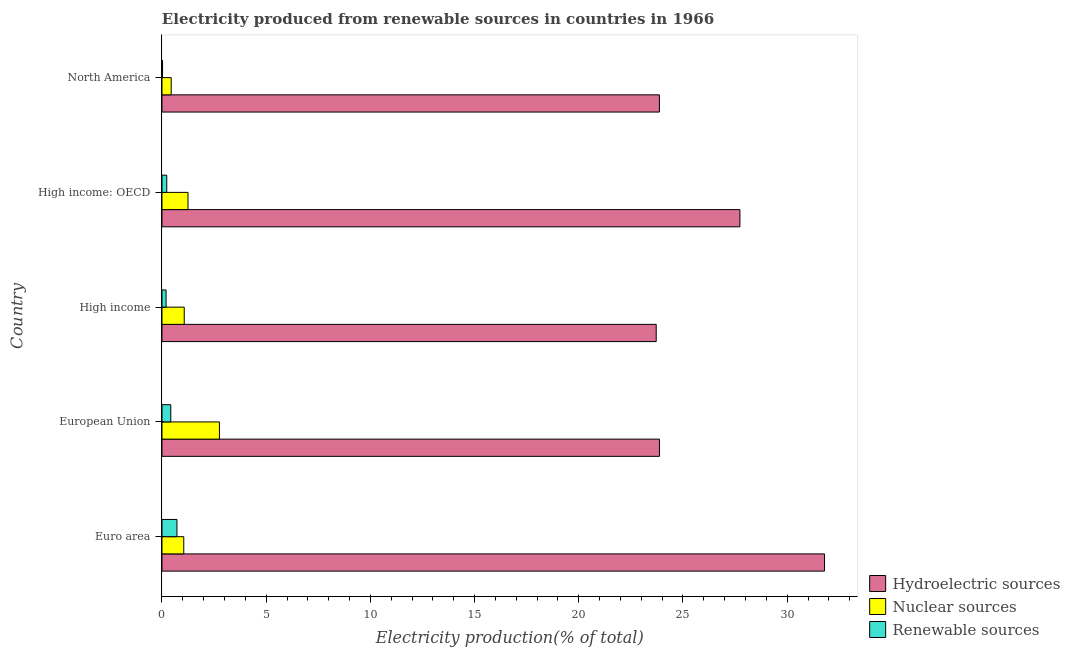How many groups of bars are there?
Provide a short and direct response. 5. Are the number of bars per tick equal to the number of legend labels?
Offer a terse response. Yes. How many bars are there on the 4th tick from the top?
Ensure brevity in your answer.  3. What is the percentage of electricity produced by nuclear sources in High income: OECD?
Give a very brief answer. 1.25. Across all countries, what is the maximum percentage of electricity produced by renewable sources?
Give a very brief answer. 0.72. Across all countries, what is the minimum percentage of electricity produced by hydroelectric sources?
Your answer should be very brief. 23.72. In which country was the percentage of electricity produced by renewable sources minimum?
Keep it short and to the point. North America. What is the total percentage of electricity produced by hydroelectric sources in the graph?
Ensure brevity in your answer.  130.98. What is the difference between the percentage of electricity produced by renewable sources in High income: OECD and that in North America?
Your response must be concise. 0.2. What is the difference between the percentage of electricity produced by nuclear sources in High income and the percentage of electricity produced by renewable sources in High income: OECD?
Make the answer very short. 0.84. What is the average percentage of electricity produced by renewable sources per country?
Offer a very short reply. 0.32. What is the difference between the percentage of electricity produced by renewable sources and percentage of electricity produced by hydroelectric sources in North America?
Provide a short and direct response. -23.84. What is the ratio of the percentage of electricity produced by hydroelectric sources in Euro area to that in European Union?
Provide a succinct answer. 1.33. Is the difference between the percentage of electricity produced by hydroelectric sources in High income and High income: OECD greater than the difference between the percentage of electricity produced by renewable sources in High income and High income: OECD?
Give a very brief answer. No. What is the difference between the highest and the second highest percentage of electricity produced by renewable sources?
Make the answer very short. 0.3. What is the difference between the highest and the lowest percentage of electricity produced by hydroelectric sources?
Your answer should be compact. 8.08. Is the sum of the percentage of electricity produced by hydroelectric sources in High income and High income: OECD greater than the maximum percentage of electricity produced by nuclear sources across all countries?
Keep it short and to the point. Yes. What does the 1st bar from the top in North America represents?
Your answer should be compact. Renewable sources. What does the 3rd bar from the bottom in North America represents?
Give a very brief answer. Renewable sources. Are all the bars in the graph horizontal?
Make the answer very short. Yes. How many countries are there in the graph?
Provide a succinct answer. 5. What is the difference between two consecutive major ticks on the X-axis?
Give a very brief answer. 5. Where does the legend appear in the graph?
Make the answer very short. Bottom right. How are the legend labels stacked?
Provide a succinct answer. Vertical. What is the title of the graph?
Your answer should be very brief. Electricity produced from renewable sources in countries in 1966. Does "Industry" appear as one of the legend labels in the graph?
Ensure brevity in your answer.  No. What is the label or title of the X-axis?
Offer a very short reply. Electricity production(% of total). What is the Electricity production(% of total) of Hydroelectric sources in Euro area?
Keep it short and to the point. 31.79. What is the Electricity production(% of total) in Nuclear sources in Euro area?
Keep it short and to the point. 1.04. What is the Electricity production(% of total) in Renewable sources in Euro area?
Offer a terse response. 0.72. What is the Electricity production(% of total) in Hydroelectric sources in European Union?
Offer a terse response. 23.87. What is the Electricity production(% of total) in Nuclear sources in European Union?
Your answer should be very brief. 2.76. What is the Electricity production(% of total) in Renewable sources in European Union?
Your answer should be very brief. 0.42. What is the Electricity production(% of total) in Hydroelectric sources in High income?
Offer a terse response. 23.72. What is the Electricity production(% of total) of Nuclear sources in High income?
Your response must be concise. 1.07. What is the Electricity production(% of total) in Renewable sources in High income?
Keep it short and to the point. 0.2. What is the Electricity production(% of total) of Hydroelectric sources in High income: OECD?
Your answer should be very brief. 27.73. What is the Electricity production(% of total) in Nuclear sources in High income: OECD?
Keep it short and to the point. 1.25. What is the Electricity production(% of total) of Renewable sources in High income: OECD?
Provide a succinct answer. 0.23. What is the Electricity production(% of total) of Hydroelectric sources in North America?
Offer a terse response. 23.87. What is the Electricity production(% of total) of Nuclear sources in North America?
Offer a very short reply. 0.44. What is the Electricity production(% of total) of Renewable sources in North America?
Make the answer very short. 0.03. Across all countries, what is the maximum Electricity production(% of total) in Hydroelectric sources?
Make the answer very short. 31.79. Across all countries, what is the maximum Electricity production(% of total) of Nuclear sources?
Keep it short and to the point. 2.76. Across all countries, what is the maximum Electricity production(% of total) in Renewable sources?
Your answer should be compact. 0.72. Across all countries, what is the minimum Electricity production(% of total) of Hydroelectric sources?
Ensure brevity in your answer.  23.72. Across all countries, what is the minimum Electricity production(% of total) in Nuclear sources?
Give a very brief answer. 0.44. Across all countries, what is the minimum Electricity production(% of total) in Renewable sources?
Offer a very short reply. 0.03. What is the total Electricity production(% of total) in Hydroelectric sources in the graph?
Provide a short and direct response. 130.98. What is the total Electricity production(% of total) in Nuclear sources in the graph?
Offer a very short reply. 6.56. What is the total Electricity production(% of total) in Renewable sources in the graph?
Offer a very short reply. 1.59. What is the difference between the Electricity production(% of total) in Hydroelectric sources in Euro area and that in European Union?
Your answer should be compact. 7.92. What is the difference between the Electricity production(% of total) of Nuclear sources in Euro area and that in European Union?
Make the answer very short. -1.71. What is the difference between the Electricity production(% of total) in Renewable sources in Euro area and that in European Union?
Provide a short and direct response. 0.3. What is the difference between the Electricity production(% of total) in Hydroelectric sources in Euro area and that in High income?
Keep it short and to the point. 8.08. What is the difference between the Electricity production(% of total) of Nuclear sources in Euro area and that in High income?
Your answer should be very brief. -0.02. What is the difference between the Electricity production(% of total) of Renewable sources in Euro area and that in High income?
Make the answer very short. 0.52. What is the difference between the Electricity production(% of total) of Hydroelectric sources in Euro area and that in High income: OECD?
Provide a succinct answer. 4.06. What is the difference between the Electricity production(% of total) of Nuclear sources in Euro area and that in High income: OECD?
Offer a terse response. -0.2. What is the difference between the Electricity production(% of total) of Renewable sources in Euro area and that in High income: OECD?
Make the answer very short. 0.49. What is the difference between the Electricity production(% of total) in Hydroelectric sources in Euro area and that in North America?
Offer a very short reply. 7.92. What is the difference between the Electricity production(% of total) in Nuclear sources in Euro area and that in North America?
Keep it short and to the point. 0.6. What is the difference between the Electricity production(% of total) in Renewable sources in Euro area and that in North America?
Give a very brief answer. 0.69. What is the difference between the Electricity production(% of total) of Hydroelectric sources in European Union and that in High income?
Offer a terse response. 0.16. What is the difference between the Electricity production(% of total) in Nuclear sources in European Union and that in High income?
Give a very brief answer. 1.69. What is the difference between the Electricity production(% of total) of Renewable sources in European Union and that in High income?
Make the answer very short. 0.23. What is the difference between the Electricity production(% of total) of Hydroelectric sources in European Union and that in High income: OECD?
Ensure brevity in your answer.  -3.86. What is the difference between the Electricity production(% of total) of Nuclear sources in European Union and that in High income: OECD?
Provide a short and direct response. 1.51. What is the difference between the Electricity production(% of total) of Renewable sources in European Union and that in High income: OECD?
Your answer should be compact. 0.19. What is the difference between the Electricity production(% of total) of Hydroelectric sources in European Union and that in North America?
Give a very brief answer. 0. What is the difference between the Electricity production(% of total) in Nuclear sources in European Union and that in North America?
Make the answer very short. 2.31. What is the difference between the Electricity production(% of total) of Renewable sources in European Union and that in North America?
Offer a very short reply. 0.39. What is the difference between the Electricity production(% of total) in Hydroelectric sources in High income and that in High income: OECD?
Your answer should be very brief. -4.02. What is the difference between the Electricity production(% of total) of Nuclear sources in High income and that in High income: OECD?
Your answer should be compact. -0.18. What is the difference between the Electricity production(% of total) in Renewable sources in High income and that in High income: OECD?
Provide a short and direct response. -0.03. What is the difference between the Electricity production(% of total) in Hydroelectric sources in High income and that in North America?
Make the answer very short. -0.15. What is the difference between the Electricity production(% of total) in Nuclear sources in High income and that in North America?
Provide a succinct answer. 0.63. What is the difference between the Electricity production(% of total) in Renewable sources in High income and that in North America?
Your answer should be very brief. 0.17. What is the difference between the Electricity production(% of total) of Hydroelectric sources in High income: OECD and that in North America?
Your response must be concise. 3.86. What is the difference between the Electricity production(% of total) in Nuclear sources in High income: OECD and that in North America?
Give a very brief answer. 0.81. What is the difference between the Electricity production(% of total) of Renewable sources in High income: OECD and that in North America?
Provide a short and direct response. 0.2. What is the difference between the Electricity production(% of total) in Hydroelectric sources in Euro area and the Electricity production(% of total) in Nuclear sources in European Union?
Ensure brevity in your answer.  29.04. What is the difference between the Electricity production(% of total) of Hydroelectric sources in Euro area and the Electricity production(% of total) of Renewable sources in European Union?
Your response must be concise. 31.37. What is the difference between the Electricity production(% of total) of Nuclear sources in Euro area and the Electricity production(% of total) of Renewable sources in European Union?
Ensure brevity in your answer.  0.62. What is the difference between the Electricity production(% of total) of Hydroelectric sources in Euro area and the Electricity production(% of total) of Nuclear sources in High income?
Give a very brief answer. 30.73. What is the difference between the Electricity production(% of total) of Hydroelectric sources in Euro area and the Electricity production(% of total) of Renewable sources in High income?
Your answer should be very brief. 31.6. What is the difference between the Electricity production(% of total) in Nuclear sources in Euro area and the Electricity production(% of total) in Renewable sources in High income?
Provide a short and direct response. 0.85. What is the difference between the Electricity production(% of total) in Hydroelectric sources in Euro area and the Electricity production(% of total) in Nuclear sources in High income: OECD?
Give a very brief answer. 30.54. What is the difference between the Electricity production(% of total) in Hydroelectric sources in Euro area and the Electricity production(% of total) in Renewable sources in High income: OECD?
Your answer should be very brief. 31.56. What is the difference between the Electricity production(% of total) in Nuclear sources in Euro area and the Electricity production(% of total) in Renewable sources in High income: OECD?
Keep it short and to the point. 0.82. What is the difference between the Electricity production(% of total) of Hydroelectric sources in Euro area and the Electricity production(% of total) of Nuclear sources in North America?
Keep it short and to the point. 31.35. What is the difference between the Electricity production(% of total) in Hydroelectric sources in Euro area and the Electricity production(% of total) in Renewable sources in North America?
Your answer should be very brief. 31.77. What is the difference between the Electricity production(% of total) of Hydroelectric sources in European Union and the Electricity production(% of total) of Nuclear sources in High income?
Your answer should be very brief. 22.8. What is the difference between the Electricity production(% of total) in Hydroelectric sources in European Union and the Electricity production(% of total) in Renewable sources in High income?
Offer a terse response. 23.68. What is the difference between the Electricity production(% of total) of Nuclear sources in European Union and the Electricity production(% of total) of Renewable sources in High income?
Provide a succinct answer. 2.56. What is the difference between the Electricity production(% of total) of Hydroelectric sources in European Union and the Electricity production(% of total) of Nuclear sources in High income: OECD?
Your answer should be compact. 22.62. What is the difference between the Electricity production(% of total) of Hydroelectric sources in European Union and the Electricity production(% of total) of Renewable sources in High income: OECD?
Your answer should be compact. 23.64. What is the difference between the Electricity production(% of total) of Nuclear sources in European Union and the Electricity production(% of total) of Renewable sources in High income: OECD?
Ensure brevity in your answer.  2.53. What is the difference between the Electricity production(% of total) in Hydroelectric sources in European Union and the Electricity production(% of total) in Nuclear sources in North America?
Make the answer very short. 23.43. What is the difference between the Electricity production(% of total) of Hydroelectric sources in European Union and the Electricity production(% of total) of Renewable sources in North America?
Your response must be concise. 23.84. What is the difference between the Electricity production(% of total) in Nuclear sources in European Union and the Electricity production(% of total) in Renewable sources in North America?
Your response must be concise. 2.73. What is the difference between the Electricity production(% of total) in Hydroelectric sources in High income and the Electricity production(% of total) in Nuclear sources in High income: OECD?
Give a very brief answer. 22.47. What is the difference between the Electricity production(% of total) in Hydroelectric sources in High income and the Electricity production(% of total) in Renewable sources in High income: OECD?
Give a very brief answer. 23.49. What is the difference between the Electricity production(% of total) in Nuclear sources in High income and the Electricity production(% of total) in Renewable sources in High income: OECD?
Provide a succinct answer. 0.84. What is the difference between the Electricity production(% of total) in Hydroelectric sources in High income and the Electricity production(% of total) in Nuclear sources in North America?
Your response must be concise. 23.27. What is the difference between the Electricity production(% of total) in Hydroelectric sources in High income and the Electricity production(% of total) in Renewable sources in North America?
Offer a very short reply. 23.69. What is the difference between the Electricity production(% of total) in Nuclear sources in High income and the Electricity production(% of total) in Renewable sources in North America?
Provide a short and direct response. 1.04. What is the difference between the Electricity production(% of total) in Hydroelectric sources in High income: OECD and the Electricity production(% of total) in Nuclear sources in North America?
Offer a terse response. 27.29. What is the difference between the Electricity production(% of total) of Hydroelectric sources in High income: OECD and the Electricity production(% of total) of Renewable sources in North America?
Your answer should be very brief. 27.71. What is the difference between the Electricity production(% of total) in Nuclear sources in High income: OECD and the Electricity production(% of total) in Renewable sources in North America?
Your answer should be very brief. 1.22. What is the average Electricity production(% of total) of Hydroelectric sources per country?
Your answer should be very brief. 26.2. What is the average Electricity production(% of total) in Nuclear sources per country?
Ensure brevity in your answer.  1.31. What is the average Electricity production(% of total) of Renewable sources per country?
Provide a short and direct response. 0.32. What is the difference between the Electricity production(% of total) of Hydroelectric sources and Electricity production(% of total) of Nuclear sources in Euro area?
Provide a short and direct response. 30.75. What is the difference between the Electricity production(% of total) of Hydroelectric sources and Electricity production(% of total) of Renewable sources in Euro area?
Your answer should be compact. 31.08. What is the difference between the Electricity production(% of total) of Nuclear sources and Electricity production(% of total) of Renewable sources in Euro area?
Ensure brevity in your answer.  0.33. What is the difference between the Electricity production(% of total) in Hydroelectric sources and Electricity production(% of total) in Nuclear sources in European Union?
Keep it short and to the point. 21.12. What is the difference between the Electricity production(% of total) of Hydroelectric sources and Electricity production(% of total) of Renewable sources in European Union?
Give a very brief answer. 23.45. What is the difference between the Electricity production(% of total) of Nuclear sources and Electricity production(% of total) of Renewable sources in European Union?
Ensure brevity in your answer.  2.33. What is the difference between the Electricity production(% of total) of Hydroelectric sources and Electricity production(% of total) of Nuclear sources in High income?
Your answer should be compact. 22.65. What is the difference between the Electricity production(% of total) in Hydroelectric sources and Electricity production(% of total) in Renewable sources in High income?
Your answer should be very brief. 23.52. What is the difference between the Electricity production(% of total) in Nuclear sources and Electricity production(% of total) in Renewable sources in High income?
Give a very brief answer. 0.87. What is the difference between the Electricity production(% of total) of Hydroelectric sources and Electricity production(% of total) of Nuclear sources in High income: OECD?
Make the answer very short. 26.48. What is the difference between the Electricity production(% of total) of Hydroelectric sources and Electricity production(% of total) of Renewable sources in High income: OECD?
Ensure brevity in your answer.  27.5. What is the difference between the Electricity production(% of total) of Hydroelectric sources and Electricity production(% of total) of Nuclear sources in North America?
Your response must be concise. 23.43. What is the difference between the Electricity production(% of total) in Hydroelectric sources and Electricity production(% of total) in Renewable sources in North America?
Provide a succinct answer. 23.84. What is the difference between the Electricity production(% of total) in Nuclear sources and Electricity production(% of total) in Renewable sources in North America?
Your response must be concise. 0.41. What is the ratio of the Electricity production(% of total) of Hydroelectric sources in Euro area to that in European Union?
Your response must be concise. 1.33. What is the ratio of the Electricity production(% of total) of Nuclear sources in Euro area to that in European Union?
Keep it short and to the point. 0.38. What is the ratio of the Electricity production(% of total) in Renewable sources in Euro area to that in European Union?
Provide a succinct answer. 1.7. What is the ratio of the Electricity production(% of total) in Hydroelectric sources in Euro area to that in High income?
Give a very brief answer. 1.34. What is the ratio of the Electricity production(% of total) in Nuclear sources in Euro area to that in High income?
Give a very brief answer. 0.98. What is the ratio of the Electricity production(% of total) of Renewable sources in Euro area to that in High income?
Your response must be concise. 3.66. What is the ratio of the Electricity production(% of total) in Hydroelectric sources in Euro area to that in High income: OECD?
Keep it short and to the point. 1.15. What is the ratio of the Electricity production(% of total) of Nuclear sources in Euro area to that in High income: OECD?
Your answer should be compact. 0.84. What is the ratio of the Electricity production(% of total) of Renewable sources in Euro area to that in High income: OECD?
Your answer should be very brief. 3.13. What is the ratio of the Electricity production(% of total) of Hydroelectric sources in Euro area to that in North America?
Offer a terse response. 1.33. What is the ratio of the Electricity production(% of total) in Nuclear sources in Euro area to that in North America?
Provide a short and direct response. 2.36. What is the ratio of the Electricity production(% of total) of Renewable sources in Euro area to that in North America?
Offer a very short reply. 25.74. What is the ratio of the Electricity production(% of total) in Hydroelectric sources in European Union to that in High income?
Give a very brief answer. 1.01. What is the ratio of the Electricity production(% of total) in Nuclear sources in European Union to that in High income?
Your answer should be very brief. 2.58. What is the ratio of the Electricity production(% of total) of Renewable sources in European Union to that in High income?
Provide a short and direct response. 2.15. What is the ratio of the Electricity production(% of total) in Hydroelectric sources in European Union to that in High income: OECD?
Provide a short and direct response. 0.86. What is the ratio of the Electricity production(% of total) of Nuclear sources in European Union to that in High income: OECD?
Make the answer very short. 2.21. What is the ratio of the Electricity production(% of total) in Renewable sources in European Union to that in High income: OECD?
Make the answer very short. 1.84. What is the ratio of the Electricity production(% of total) of Hydroelectric sources in European Union to that in North America?
Offer a very short reply. 1. What is the ratio of the Electricity production(% of total) in Nuclear sources in European Union to that in North America?
Your response must be concise. 6.23. What is the ratio of the Electricity production(% of total) of Renewable sources in European Union to that in North America?
Offer a terse response. 15.13. What is the ratio of the Electricity production(% of total) of Hydroelectric sources in High income to that in High income: OECD?
Provide a short and direct response. 0.86. What is the ratio of the Electricity production(% of total) in Nuclear sources in High income to that in High income: OECD?
Your answer should be compact. 0.86. What is the ratio of the Electricity production(% of total) in Renewable sources in High income to that in High income: OECD?
Offer a terse response. 0.86. What is the ratio of the Electricity production(% of total) in Hydroelectric sources in High income to that in North America?
Keep it short and to the point. 0.99. What is the ratio of the Electricity production(% of total) in Nuclear sources in High income to that in North America?
Your answer should be very brief. 2.41. What is the ratio of the Electricity production(% of total) of Renewable sources in High income to that in North America?
Make the answer very short. 7.04. What is the ratio of the Electricity production(% of total) of Hydroelectric sources in High income: OECD to that in North America?
Your answer should be compact. 1.16. What is the ratio of the Electricity production(% of total) in Nuclear sources in High income: OECD to that in North America?
Provide a succinct answer. 2.82. What is the ratio of the Electricity production(% of total) of Renewable sources in High income: OECD to that in North America?
Ensure brevity in your answer.  8.23. What is the difference between the highest and the second highest Electricity production(% of total) of Hydroelectric sources?
Provide a short and direct response. 4.06. What is the difference between the highest and the second highest Electricity production(% of total) of Nuclear sources?
Provide a short and direct response. 1.51. What is the difference between the highest and the second highest Electricity production(% of total) of Renewable sources?
Provide a succinct answer. 0.3. What is the difference between the highest and the lowest Electricity production(% of total) in Hydroelectric sources?
Ensure brevity in your answer.  8.08. What is the difference between the highest and the lowest Electricity production(% of total) of Nuclear sources?
Your answer should be compact. 2.31. What is the difference between the highest and the lowest Electricity production(% of total) in Renewable sources?
Your answer should be compact. 0.69. 